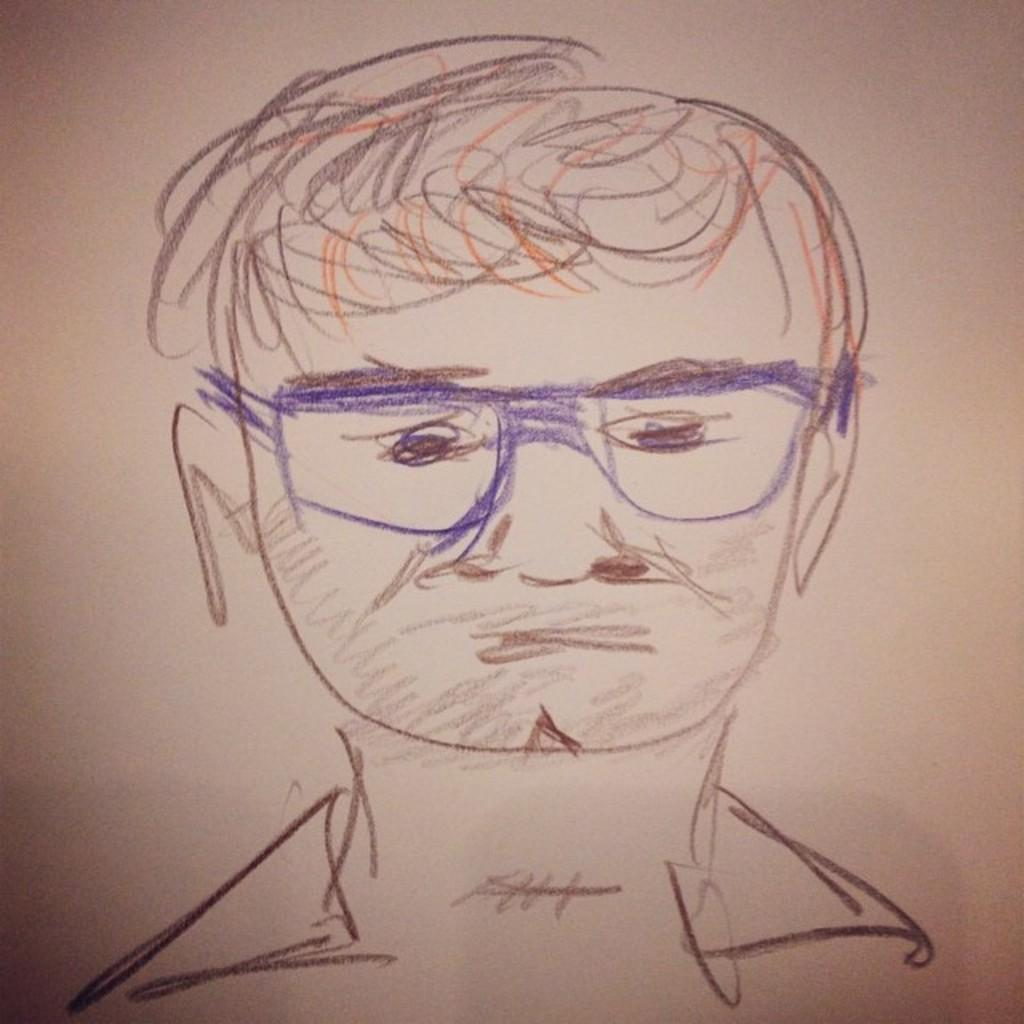What is depicted in the image? There is a drawing of a man in the image. What color is the background of the image? The background of the image is white. How many horns does the man have in the image? There are no horns present in the image; it features a drawing of a man with no horns. What type of tomatoes can be seen growing in the image? There are no tomatoes present in the image; it features a drawing of a man with no plants or vegetables. 